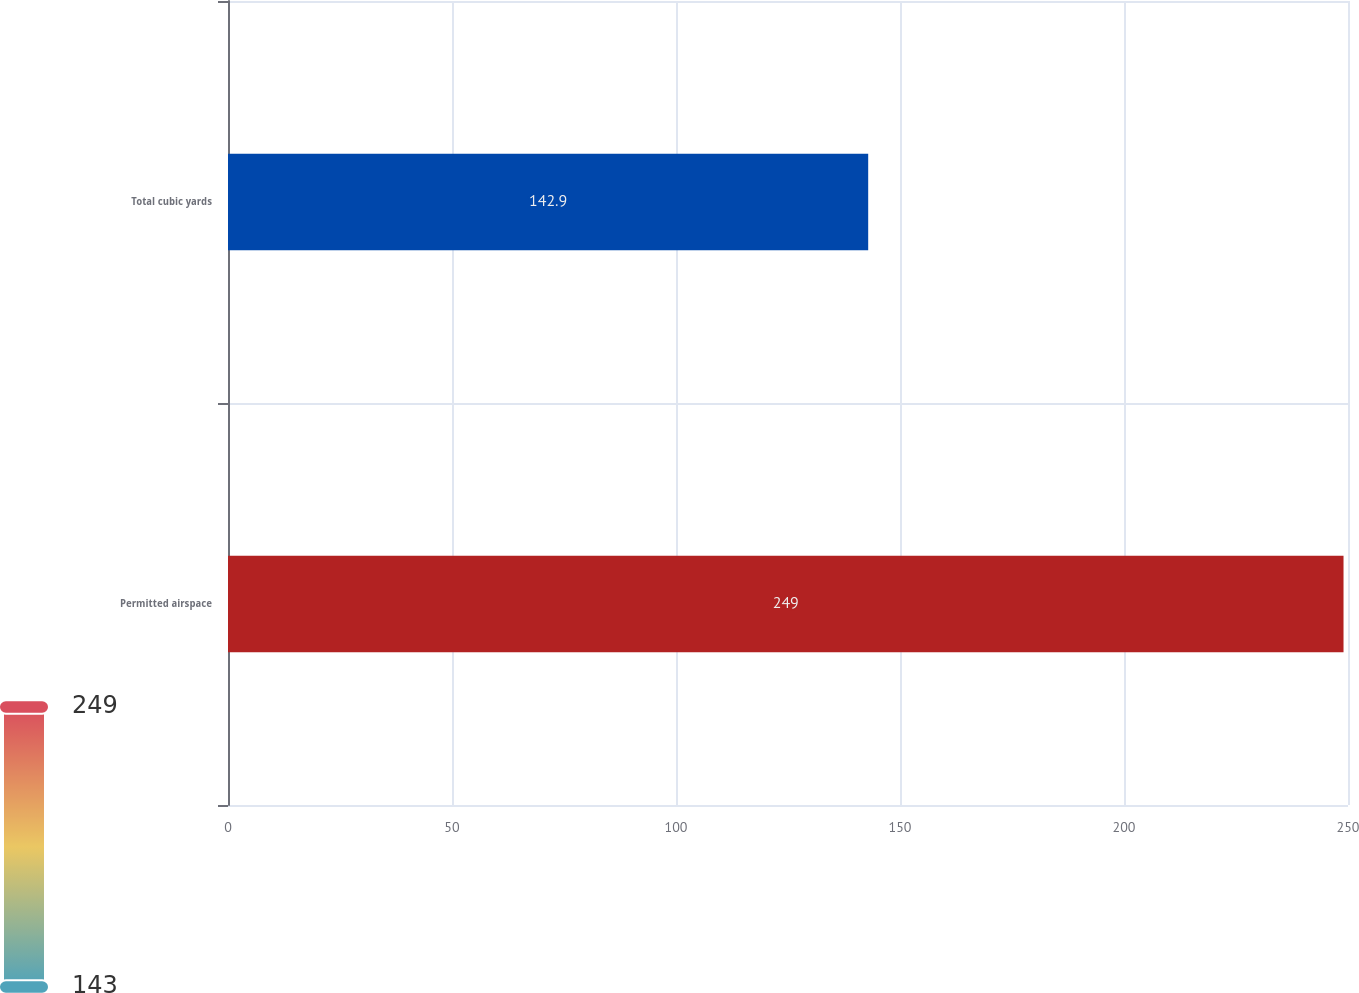Convert chart. <chart><loc_0><loc_0><loc_500><loc_500><bar_chart><fcel>Permitted airspace<fcel>Total cubic yards<nl><fcel>249<fcel>142.9<nl></chart> 